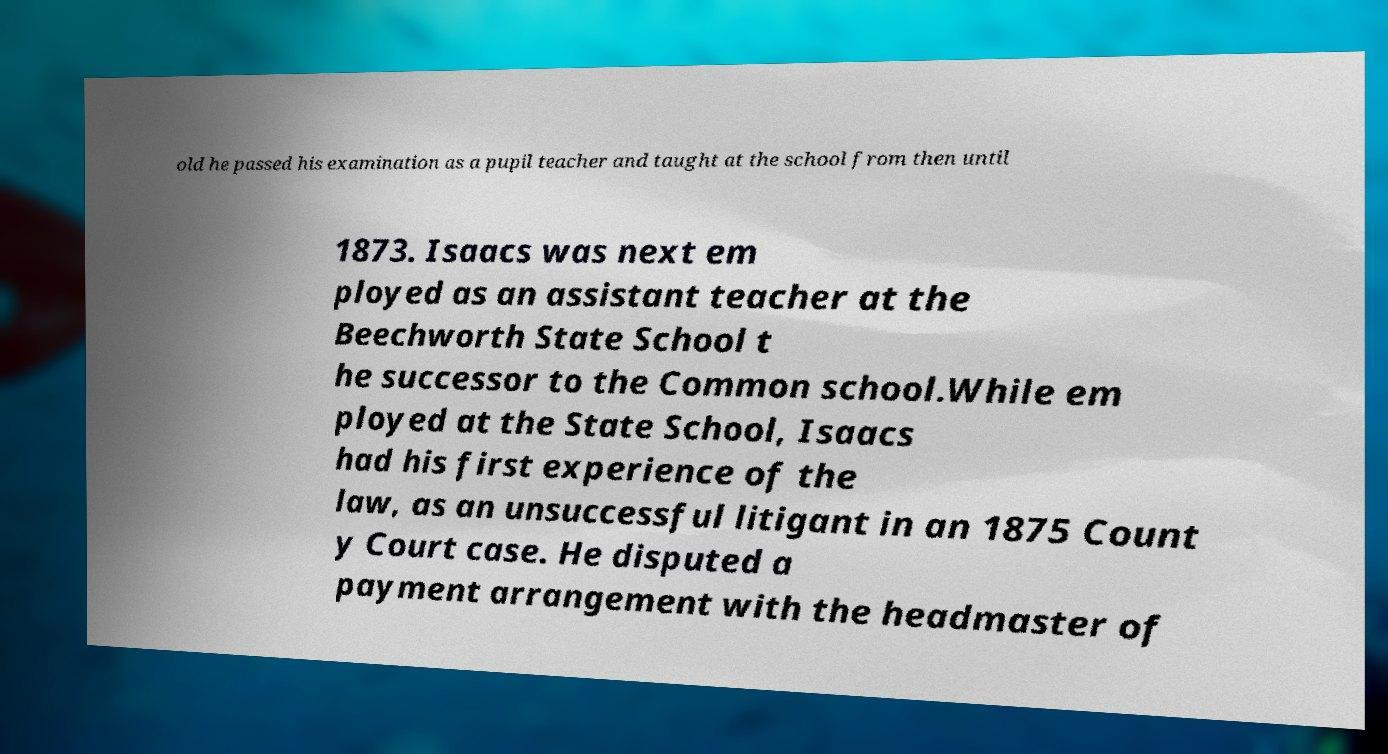Can you accurately transcribe the text from the provided image for me? old he passed his examination as a pupil teacher and taught at the school from then until 1873. Isaacs was next em ployed as an assistant teacher at the Beechworth State School t he successor to the Common school.While em ployed at the State School, Isaacs had his first experience of the law, as an unsuccessful litigant in an 1875 Count y Court case. He disputed a payment arrangement with the headmaster of 